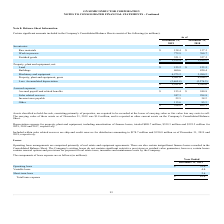According to On Semiconductor's financial document, How much is the Depreciation expense for property, plant and equipment, including amortization of finance leases for 2019? According to the financial document, $409.7 million. The relevant text states: "including amortization of finance leases, totaled $409.7 million, $359.3 million and $325.2 million for 2019, 2018 and 2017, respectively...." Also, How much is the Depreciation expense for property, plant and equipment, including amortization of finance leases for 2018? According to the financial document, $359.3 million. The relevant text states: "ization of finance leases, totaled $409.7 million, $359.3 million and $325.2 million for 2019, 2018 and 2017, respectively...." Also, How much is the Depreciation expense for property, plant and equipment, including amortization of finance leases for 2017? According to the financial document, $325.2 million. The relevant text states: "leases, totaled $409.7 million, $359.3 million and $325.2 million for 2019, 2018 and 2017, respectively...." Also, can you calculate: What is the change in Inventories: Work in process from December 31, 2018 to 2019? Based on the calculation: 772.9-760.7, the result is 12.2 (in millions). This is based on the information: "Work in process 772.9 760.7 Work in process 772.9 760.7..." The key data points involved are: 760.7, 772.9. Also, can you calculate: What is the change in Inventories: Finished goods from year ended December 31, 2018 to 2019? Based on the calculation: 321.1-327.2, the result is -6.1 (in millions). This is based on the information: "Finished goods 321.1 327.2 Finished goods 321.1 327.2..." The key data points involved are: 321.1, 327.2. Also, can you calculate: What is the average Inventories: Work in process for December 31, 2018 to 2019? To answer this question, I need to perform calculations using the financial data. The calculation is: (772.9+760.7) / 2, which equals 766.8 (in millions). This is based on the information: "Work in process 772.9 760.7 Work in process 772.9 760.7..." The key data points involved are: 760.7, 772.9. 